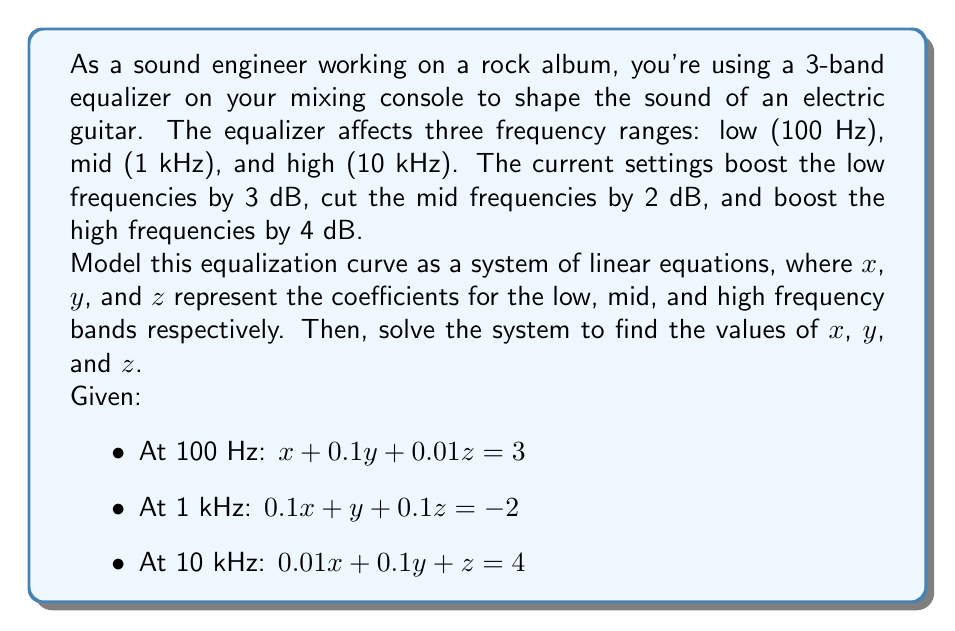Show me your answer to this math problem. To solve this system of linear equations, we'll use the Gaussian elimination method:

1) First, let's write our system in matrix form:

$$
\begin{bmatrix}
1 & 0.1 & 0.01 \\
0.1 & 1 & 0.1 \\
0.01 & 0.1 & 1
\end{bmatrix}
\begin{bmatrix}
x \\
y \\
z
\end{bmatrix}
=
\begin{bmatrix}
3 \\
-2 \\
4
\end{bmatrix}
$$

2) Now, we'll perform row operations to transform the matrix into row echelon form:

Multiply R1 by 10 and subtract from R2:
$$
\begin{bmatrix}
1 & 0.1 & 0.01 & | & 3 \\
0 & 0.99 & 0.099 & | & -5 \\
0.01 & 0.1 & 1 & | & 4
\end{bmatrix}
$$

Multiply R1 by 100 and subtract from R3:
$$
\begin{bmatrix}
1 & 0.1 & 0.01 & | & 3 \\
0 & 0.99 & 0.099 & | & -5 \\
0 & 0.09 & 0.99 & | & 1
\end{bmatrix}
$$

3) Now, we'll continue to back-substitute:

Multiply R2 by $\frac{1}{0.99}$:
$$
\begin{bmatrix}
1 & 0.1 & 0.01 & | & 3 \\
0 & 1 & 0.1 & | & -5.05 \\
0 & 0.09 & 0.99 & | & 1
\end{bmatrix}
$$

Subtract 0.09 times R2 from R3:
$$
\begin{bmatrix}
1 & 0.1 & 0.01 & | & 3 \\
0 & 1 & 0.1 & | & -5.05 \\
0 & 0 & 0.981 & | & 1.4545
\end{bmatrix}
$$

4) Now we can solve for z:

$z = 1.4545 / 0.981 = 1.4826$

5) Substitute z back into R2:

$y + 0.1(1.4826) = -5.05$
$y = -5.05 - 0.14826 = -5.1983$

6) Finally, substitute y and z back into R1:

$x + 0.1(-5.1983) + 0.01(1.4826) = 3$
$x = 3 + 0.51983 - 0.014826 = 3.505$

Therefore, the solution is:
$x = 3.505$
$y = -5.1983$
$z = 1.4826$
Answer: $x = 3.505$, $y = -5.1983$, $z = 1.4826$

These values represent the coefficients for the low, mid, and high frequency bands respectively in the equalizer's transfer function. 